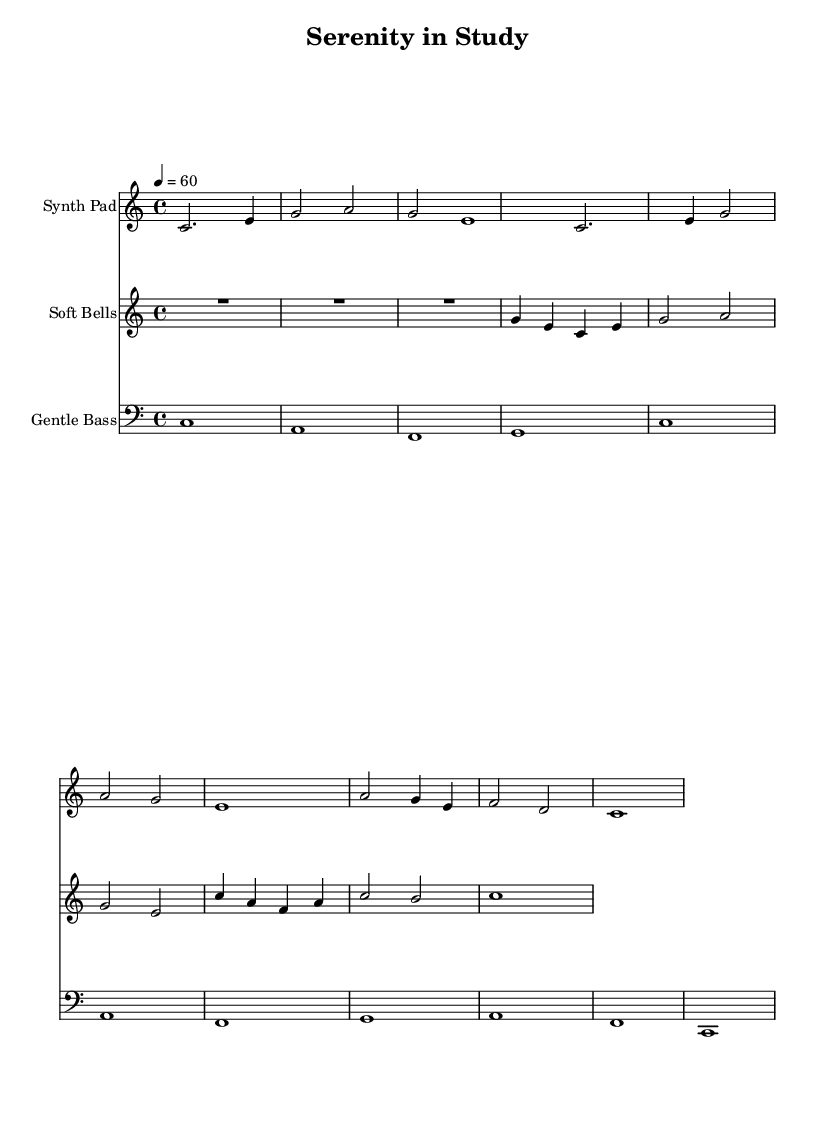What is the key signature of this music? The key signature is C major, which has no sharps or flats.
Answer: C major What is the time signature of this music? The time signature indicated is 4/4, meaning there are four beats per measure.
Answer: 4/4 What is the tempo marking for this piece? The tempo marking indicates a speed of 60 beats per minute, suggesting a slow and relaxed pace.
Answer: 60 How many measures are in the Synth Pad staff? By counting the musical phrases in the Synth Pad staff, there are a total of 6 measures.
Answer: 6 What is the lowest note played in the Gentle Bass section? Analyzing the Gentle Bass, the lowest note played is either C or F, appearing in different octaves. The lowest overall is C.
Answer: C What instruments are indicated in the score? The score names three instruments: Synth Pad, Soft Bells, and Gentle Bass.
Answer: Synth Pad, Soft Bells, Gentle Bass Which musical elements contribute to the ambient soundscape in this piece? The use of sustained notes in the Synth Pad and Soft Bells, along with minimal rhythmic variations, creates a soothing ambient texture ideal for studying.
Answer: Sustained notes and minimal rhythm 